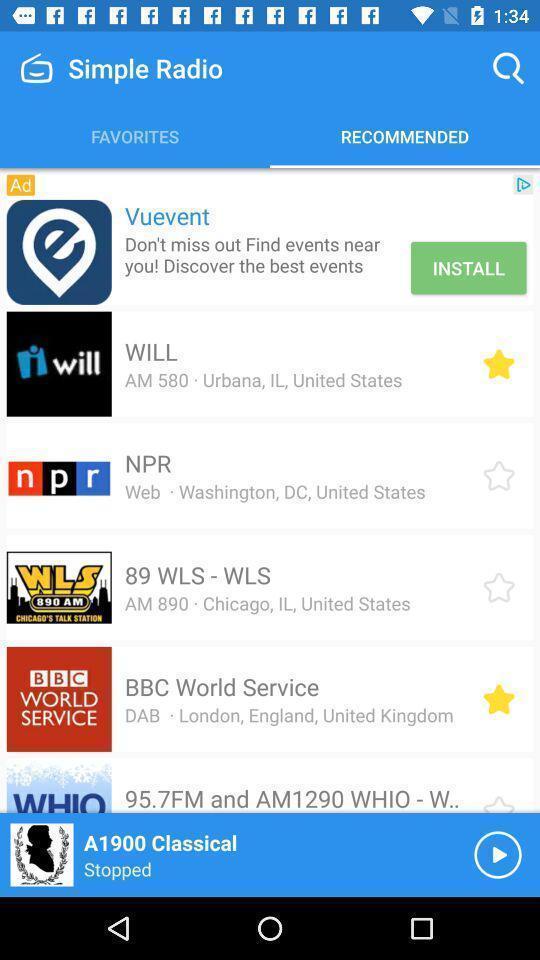What is the overall content of this screenshot? Screen shows list of recommended radios. 